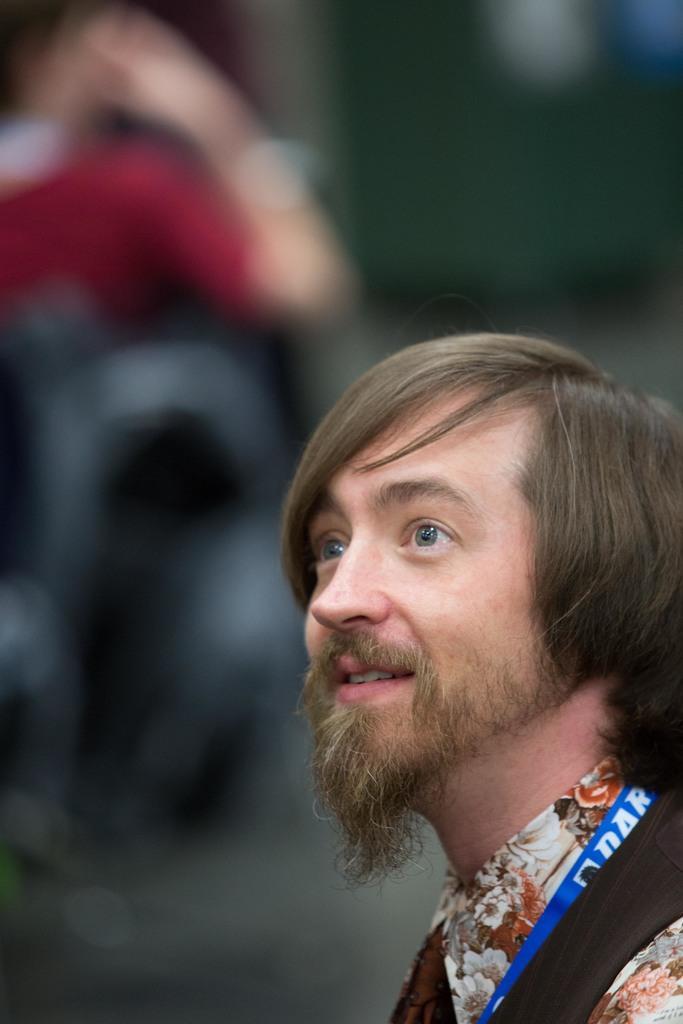Can you describe this image briefly? In this image on the right side, I can see a person. I can also see the background is blurred. 